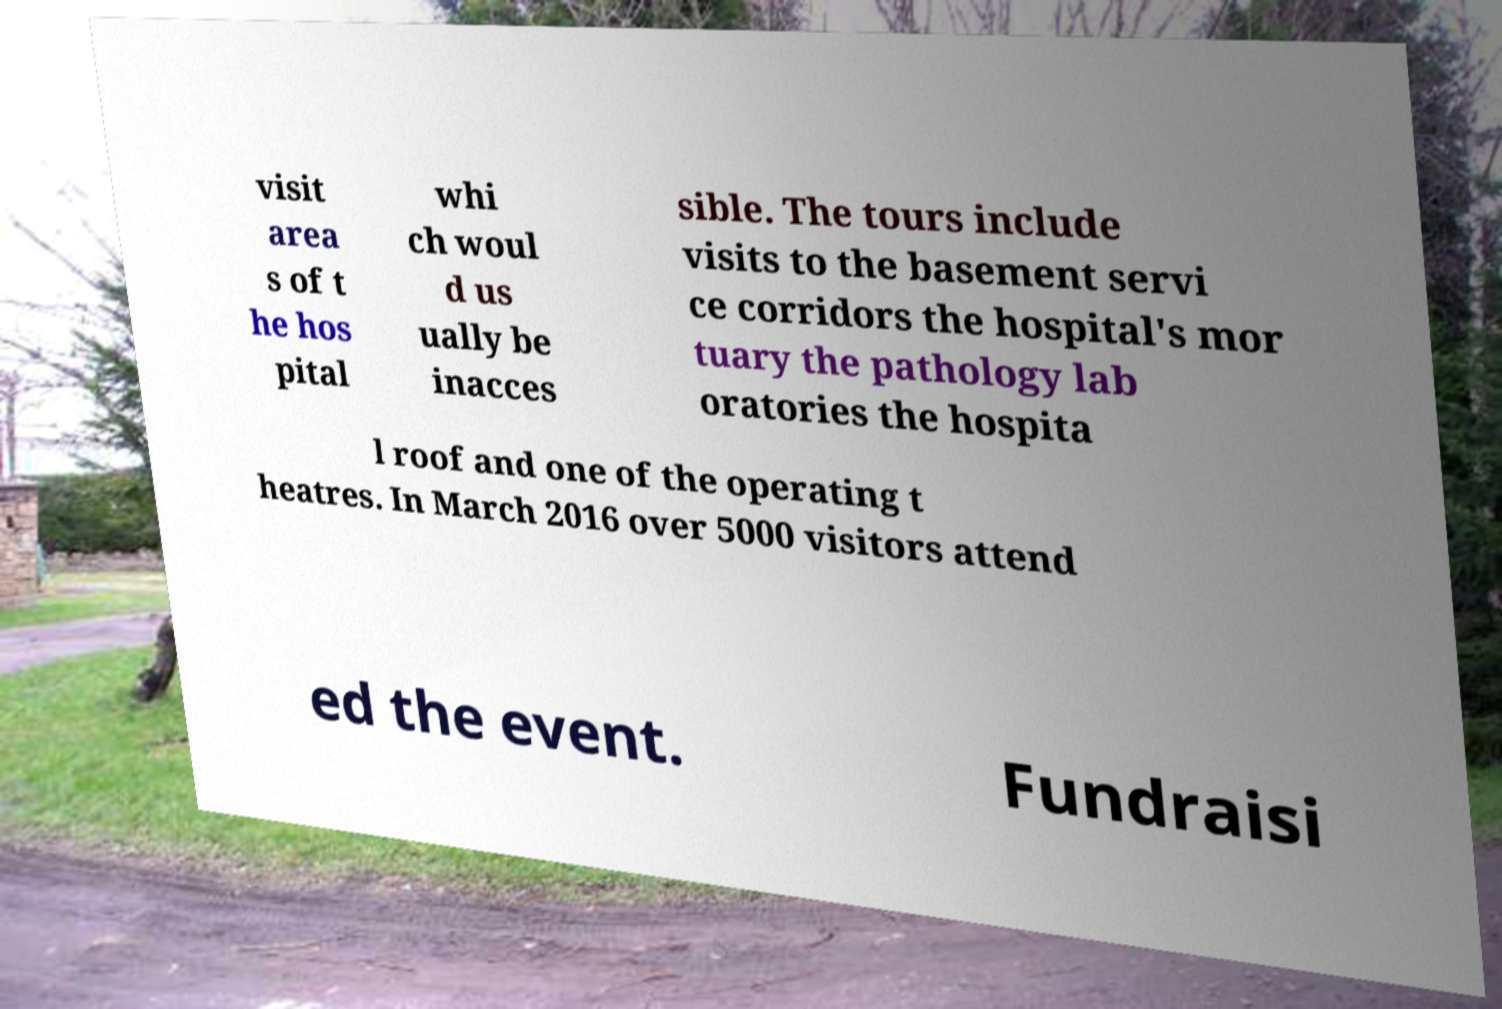For documentation purposes, I need the text within this image transcribed. Could you provide that? visit area s of t he hos pital whi ch woul d us ually be inacces sible. The tours include visits to the basement servi ce corridors the hospital's mor tuary the pathology lab oratories the hospita l roof and one of the operating t heatres. In March 2016 over 5000 visitors attend ed the event. Fundraisi 